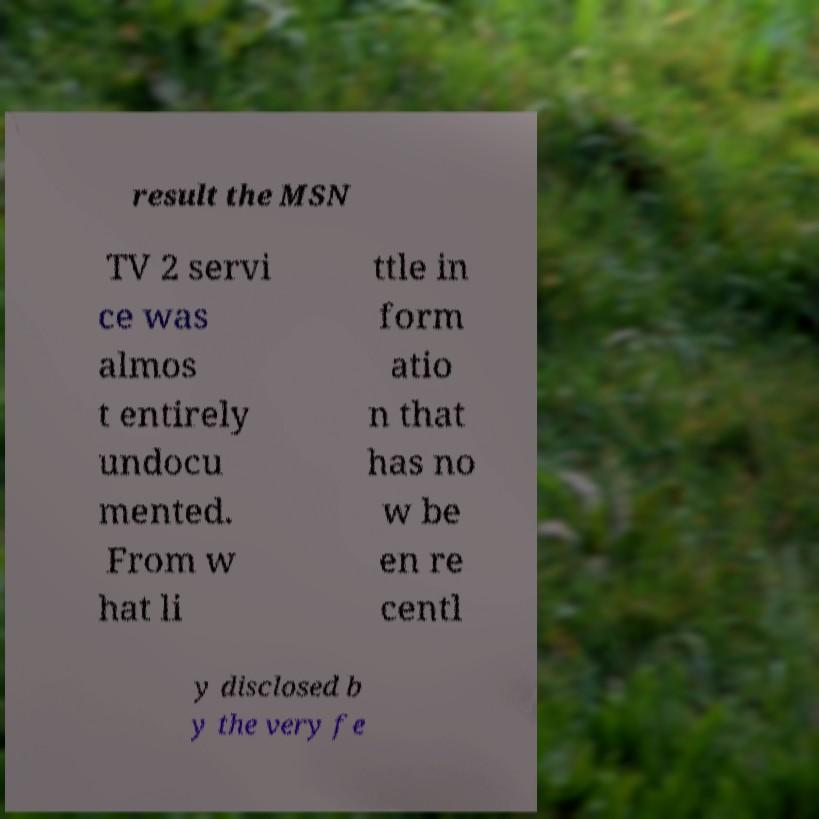There's text embedded in this image that I need extracted. Can you transcribe it verbatim? result the MSN TV 2 servi ce was almos t entirely undocu mented. From w hat li ttle in form atio n that has no w be en re centl y disclosed b y the very fe 